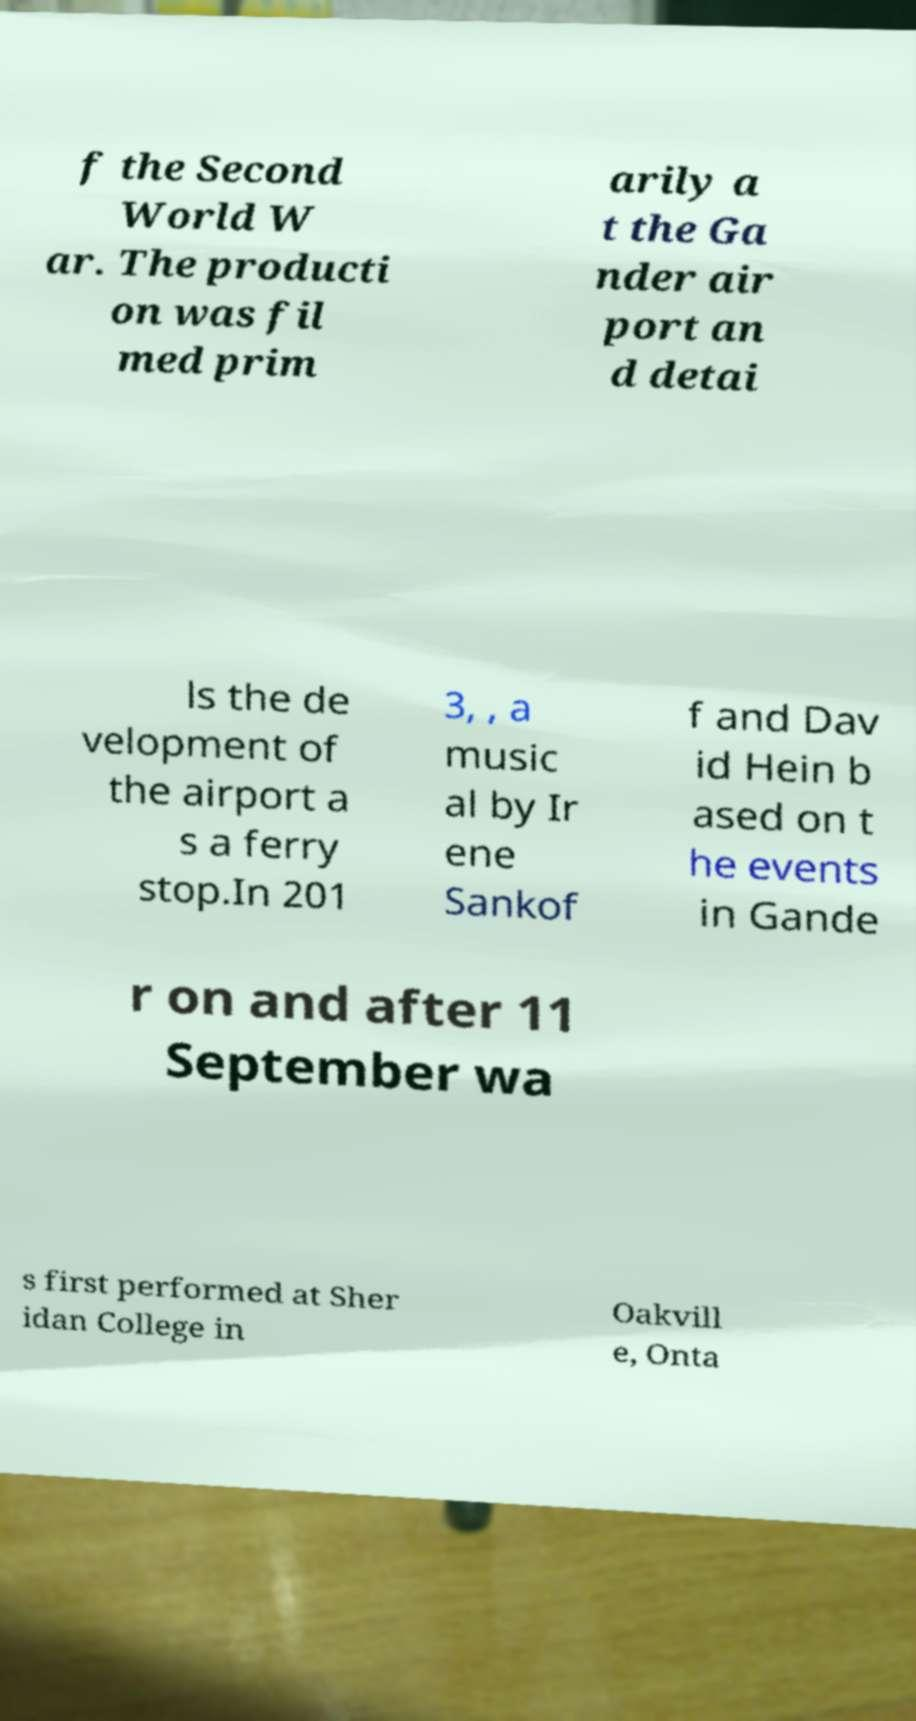Could you extract and type out the text from this image? f the Second World W ar. The producti on was fil med prim arily a t the Ga nder air port an d detai ls the de velopment of the airport a s a ferry stop.In 201 3, , a music al by Ir ene Sankof f and Dav id Hein b ased on t he events in Gande r on and after 11 September wa s first performed at Sher idan College in Oakvill e, Onta 